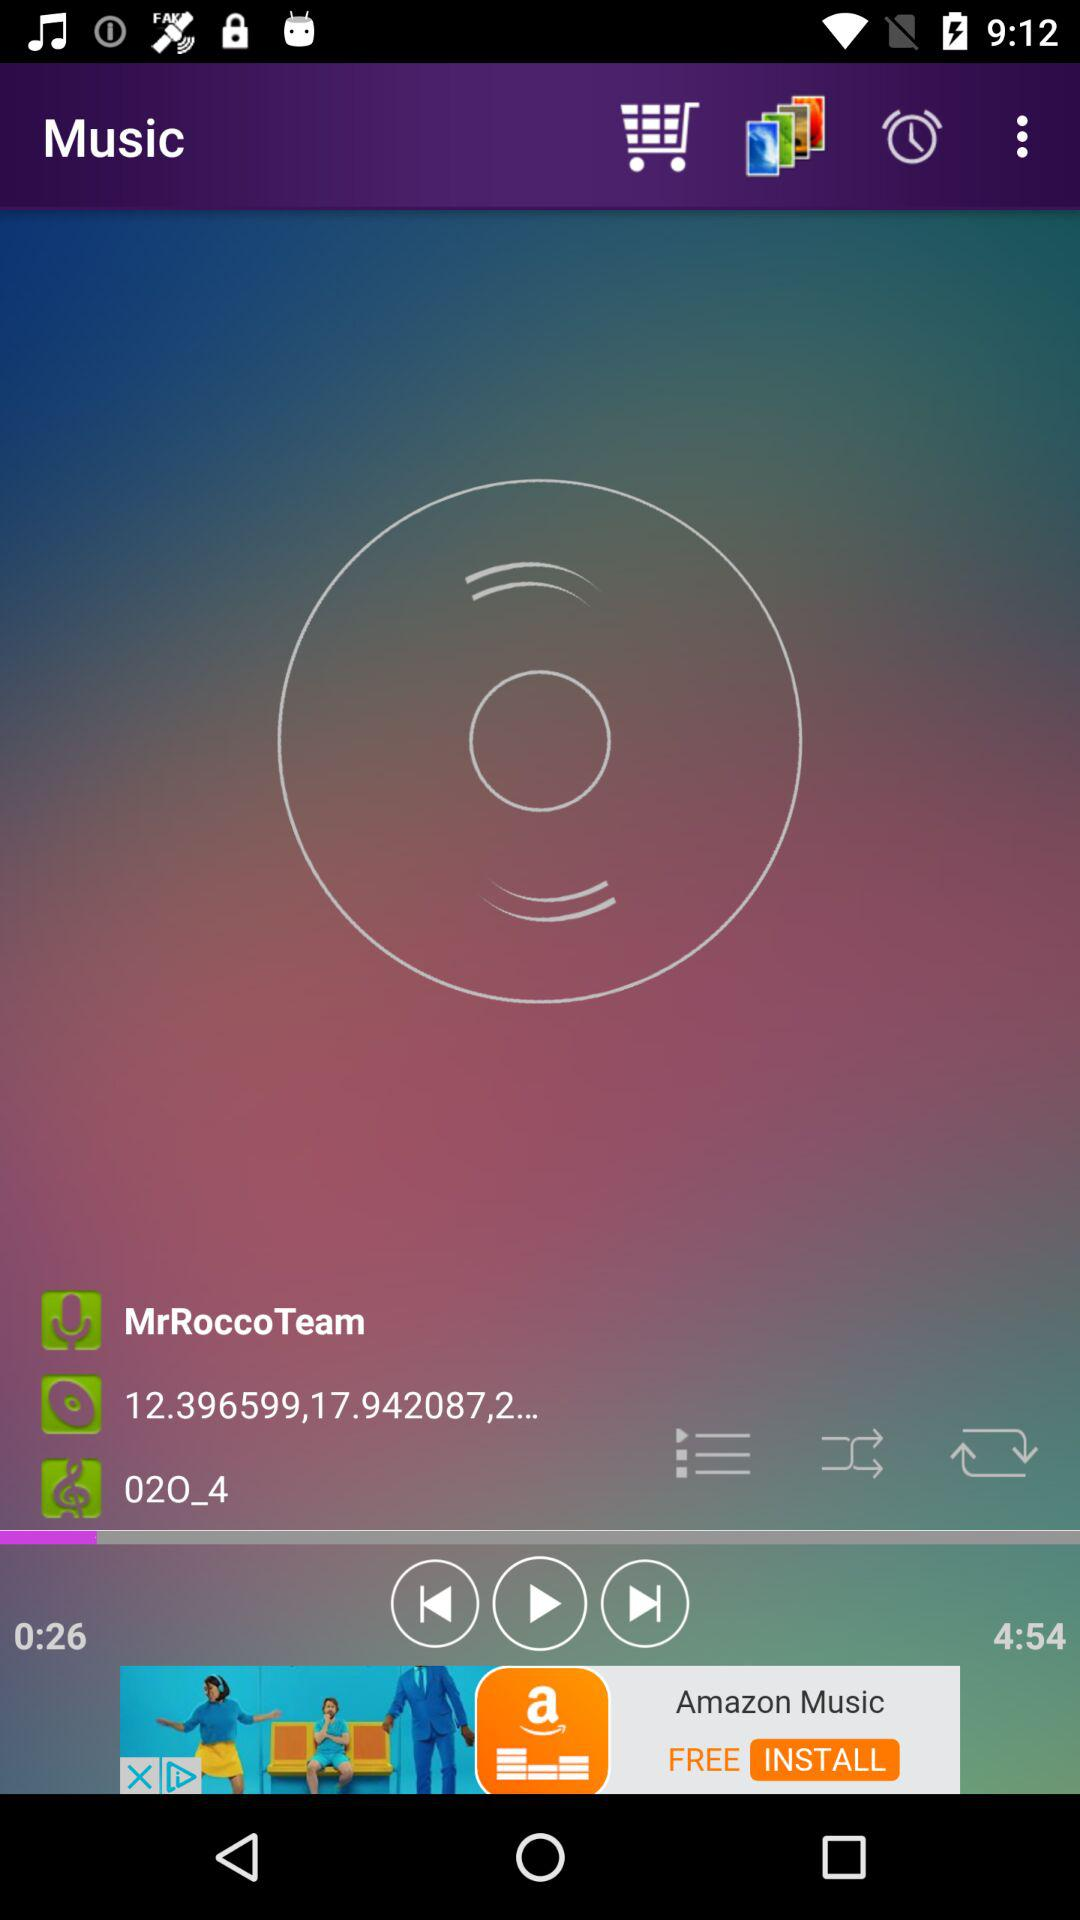For how long has the audio been played? The audio has been played for 26 seconds. 